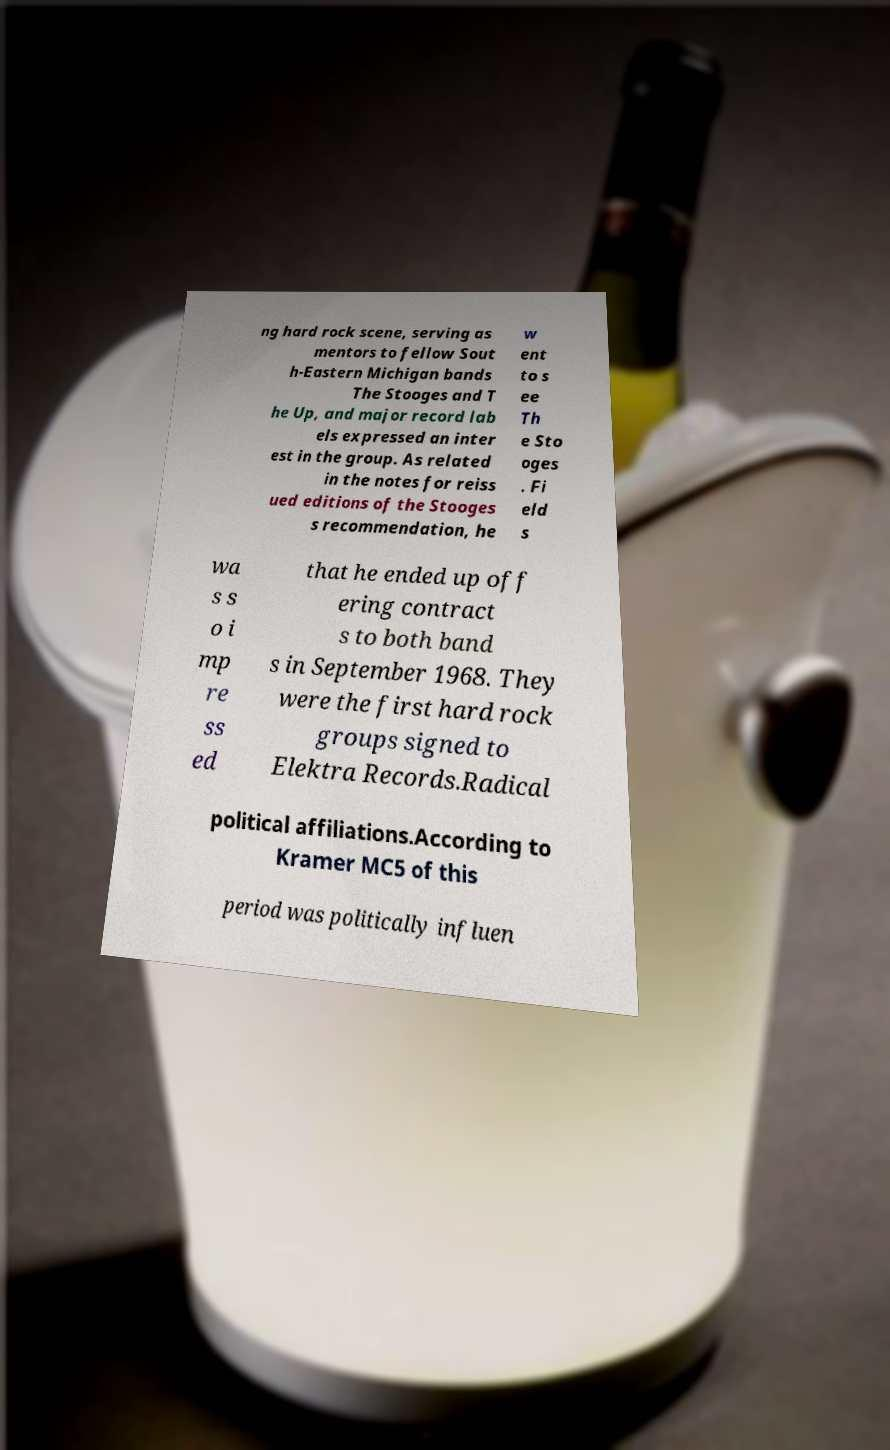What messages or text are displayed in this image? I need them in a readable, typed format. ng hard rock scene, serving as mentors to fellow Sout h-Eastern Michigan bands The Stooges and T he Up, and major record lab els expressed an inter est in the group. As related in the notes for reiss ued editions of the Stooges s recommendation, he w ent to s ee Th e Sto oges . Fi eld s wa s s o i mp re ss ed that he ended up off ering contract s to both band s in September 1968. They were the first hard rock groups signed to Elektra Records.Radical political affiliations.According to Kramer MC5 of this period was politically influen 